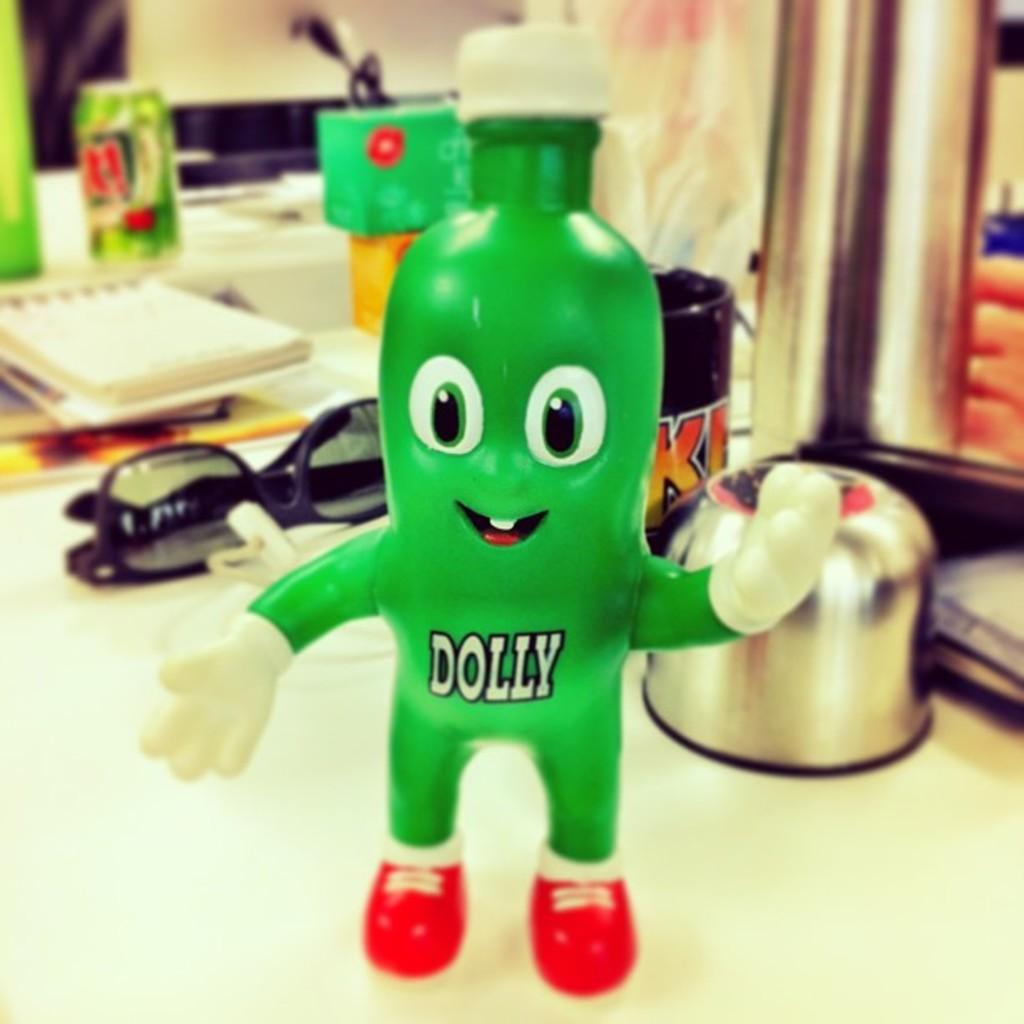What objects can be seen on the table in the image? There are papers, a doll, a cake tin, and goggles on the table in the image. Can you describe the doll in the image? The doll is one of the objects on the table in the image. What is the purpose of the cake tin in the image? The cake tin is an item on the table, but its purpose cannot be determined from the image alone. What other items are on the table in the image? There are other items on the table, but their specific nature cannot be determined from the provided facts. What type of punishment is being administered to the doll in the image? There is no indication of punishment in the image; it simply shows a doll on a table with other objects. 